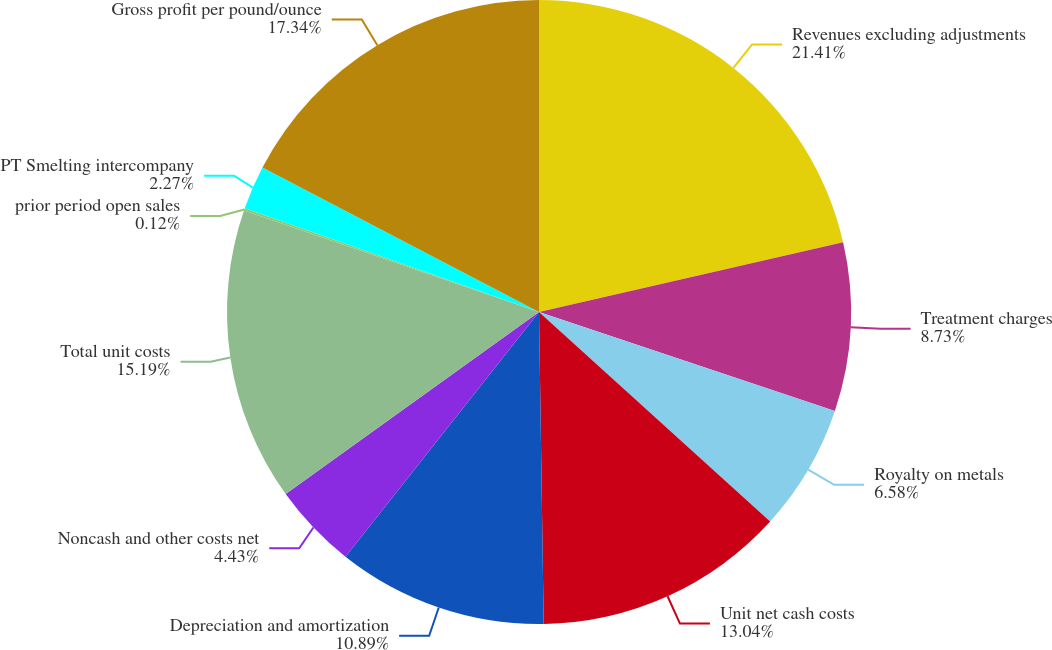<chart> <loc_0><loc_0><loc_500><loc_500><pie_chart><fcel>Revenues excluding adjustments<fcel>Treatment charges<fcel>Royalty on metals<fcel>Unit net cash costs<fcel>Depreciation and amortization<fcel>Noncash and other costs net<fcel>Total unit costs<fcel>prior period open sales<fcel>PT Smelting intercompany<fcel>Gross profit per pound/ounce<nl><fcel>21.41%<fcel>8.73%<fcel>6.58%<fcel>13.04%<fcel>10.89%<fcel>4.43%<fcel>15.19%<fcel>0.12%<fcel>2.27%<fcel>17.34%<nl></chart> 